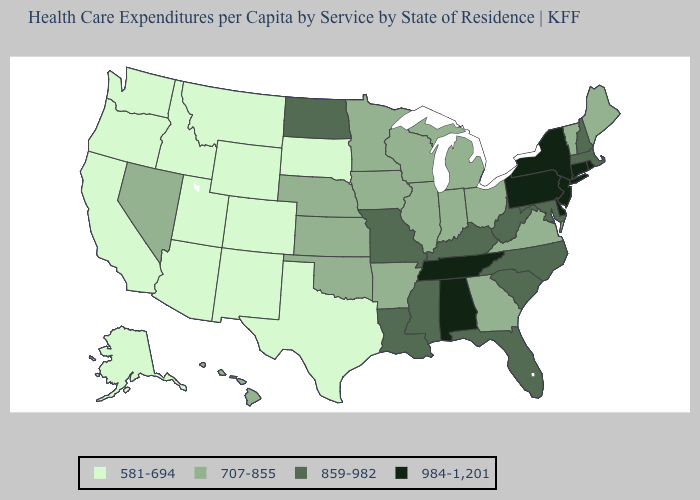Name the states that have a value in the range 984-1,201?
Write a very short answer. Alabama, Connecticut, Delaware, New Jersey, New York, Pennsylvania, Rhode Island, Tennessee. Which states have the lowest value in the West?
Quick response, please. Alaska, Arizona, California, Colorado, Idaho, Montana, New Mexico, Oregon, Utah, Washington, Wyoming. What is the value of South Carolina?
Quick response, please. 859-982. Does Utah have a lower value than Alaska?
Short answer required. No. What is the highest value in the West ?
Be succinct. 707-855. What is the lowest value in states that border Oklahoma?
Keep it brief. 581-694. What is the value of Kentucky?
Answer briefly. 859-982. Does the map have missing data?
Answer briefly. No. What is the value of Pennsylvania?
Be succinct. 984-1,201. Does the first symbol in the legend represent the smallest category?
Give a very brief answer. Yes. Among the states that border Mississippi , does Tennessee have the highest value?
Short answer required. Yes. What is the value of Minnesota?
Give a very brief answer. 707-855. Name the states that have a value in the range 707-855?
Write a very short answer. Arkansas, Georgia, Hawaii, Illinois, Indiana, Iowa, Kansas, Maine, Michigan, Minnesota, Nebraska, Nevada, Ohio, Oklahoma, Vermont, Virginia, Wisconsin. What is the value of Illinois?
Give a very brief answer. 707-855. 